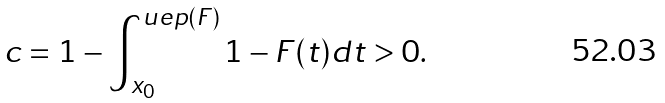Convert formula to latex. <formula><loc_0><loc_0><loc_500><loc_500>c = 1 - \int _ { x _ { 0 } } ^ { u e p ( F ) } 1 - F ( t ) d t > 0 .</formula> 